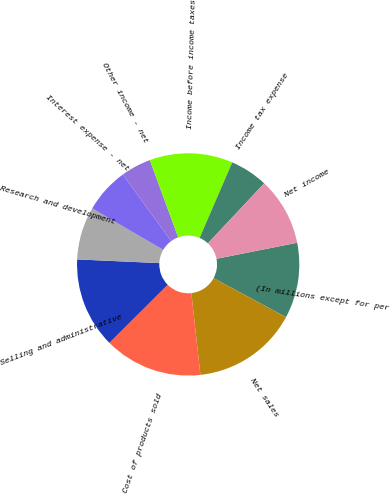<chart> <loc_0><loc_0><loc_500><loc_500><pie_chart><fcel>(In millions except for per<fcel>Net sales<fcel>Cost of products sold<fcel>Selling and administrative<fcel>Research and development<fcel>Interest expense - net<fcel>Other income - net<fcel>Income before income taxes<fcel>Income tax expense<fcel>Net income<nl><fcel>10.99%<fcel>15.38%<fcel>14.29%<fcel>13.19%<fcel>7.69%<fcel>6.59%<fcel>4.4%<fcel>12.09%<fcel>5.5%<fcel>9.89%<nl></chart> 